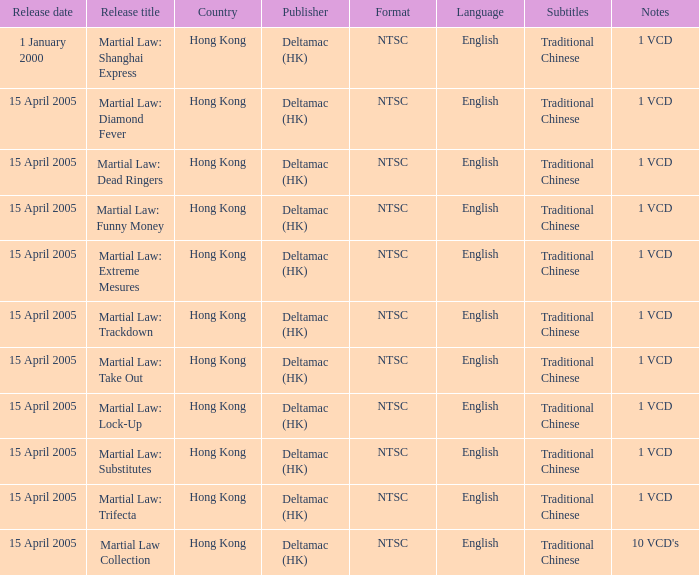Which publisher released Martial Law: Substitutes? Deltamac (HK). 